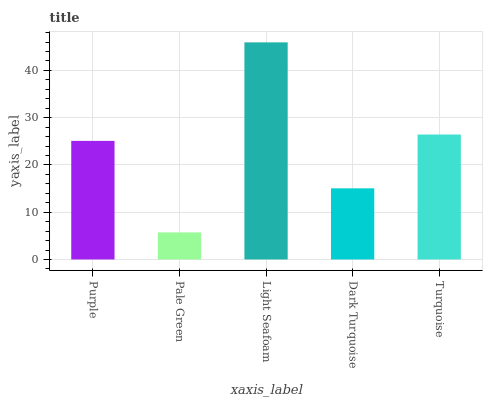Is Pale Green the minimum?
Answer yes or no. Yes. Is Light Seafoam the maximum?
Answer yes or no. Yes. Is Light Seafoam the minimum?
Answer yes or no. No. Is Pale Green the maximum?
Answer yes or no. No. Is Light Seafoam greater than Pale Green?
Answer yes or no. Yes. Is Pale Green less than Light Seafoam?
Answer yes or no. Yes. Is Pale Green greater than Light Seafoam?
Answer yes or no. No. Is Light Seafoam less than Pale Green?
Answer yes or no. No. Is Purple the high median?
Answer yes or no. Yes. Is Purple the low median?
Answer yes or no. Yes. Is Light Seafoam the high median?
Answer yes or no. No. Is Turquoise the low median?
Answer yes or no. No. 